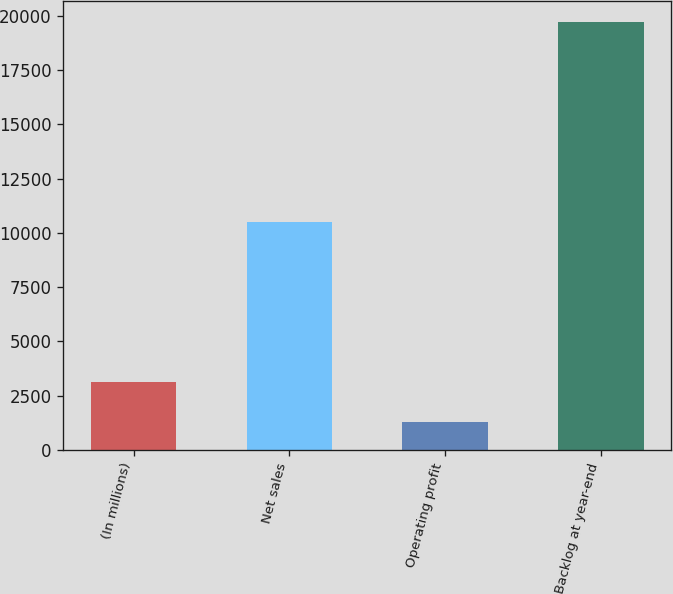Convert chart to OTSL. <chart><loc_0><loc_0><loc_500><loc_500><bar_chart><fcel>(In millions)<fcel>Net sales<fcel>Operating profit<fcel>Backlog at year-end<nl><fcel>3107.6<fcel>10519<fcel>1264<fcel>19700<nl></chart> 